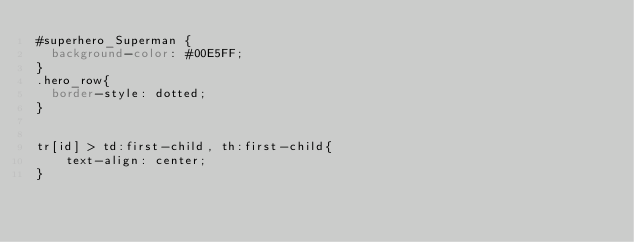<code> <loc_0><loc_0><loc_500><loc_500><_CSS_>#superhero_Superman {
  background-color: #00E5FF;
}
.hero_row{
  border-style: dotted;
}

 
tr[id] > td:first-child, th:first-child{
    text-align: center;
}


</code> 